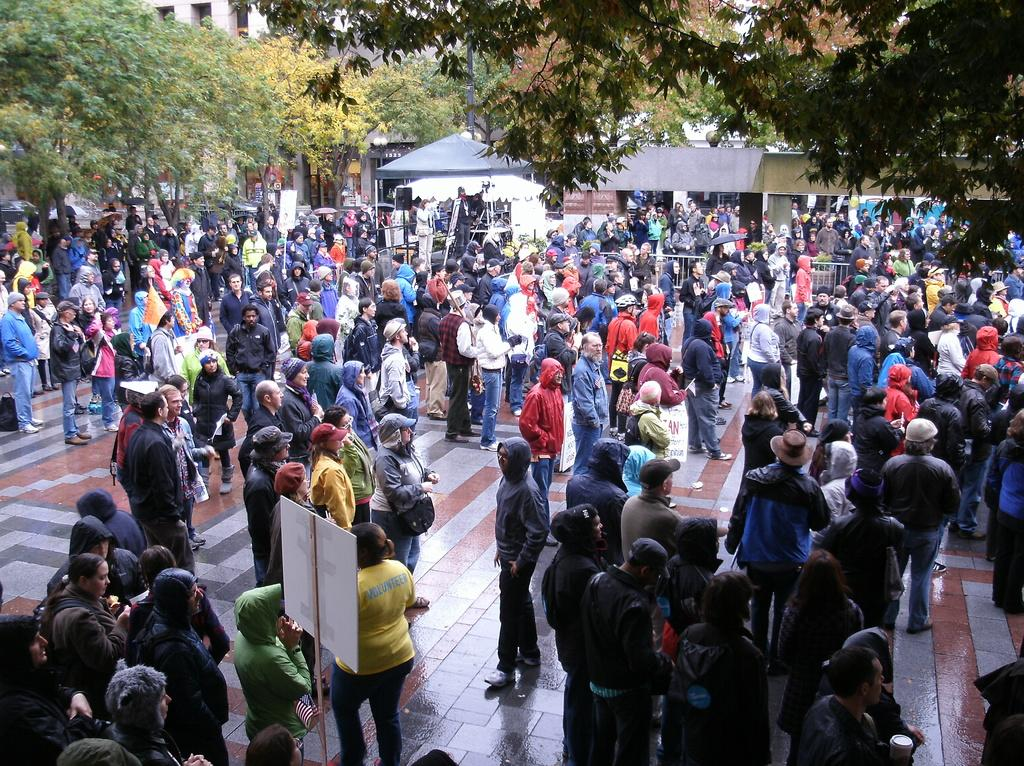How many people can be seen in the image? There are many people standing in the image. What is located at the bottom of the image? There is a board at the bottom of the image. What can be seen in the background of the image? There are trees and buildings in the background of the image. What type of jeans are the people wearing in the image? There is no information about the type of clothing the people are wearing in the image. 